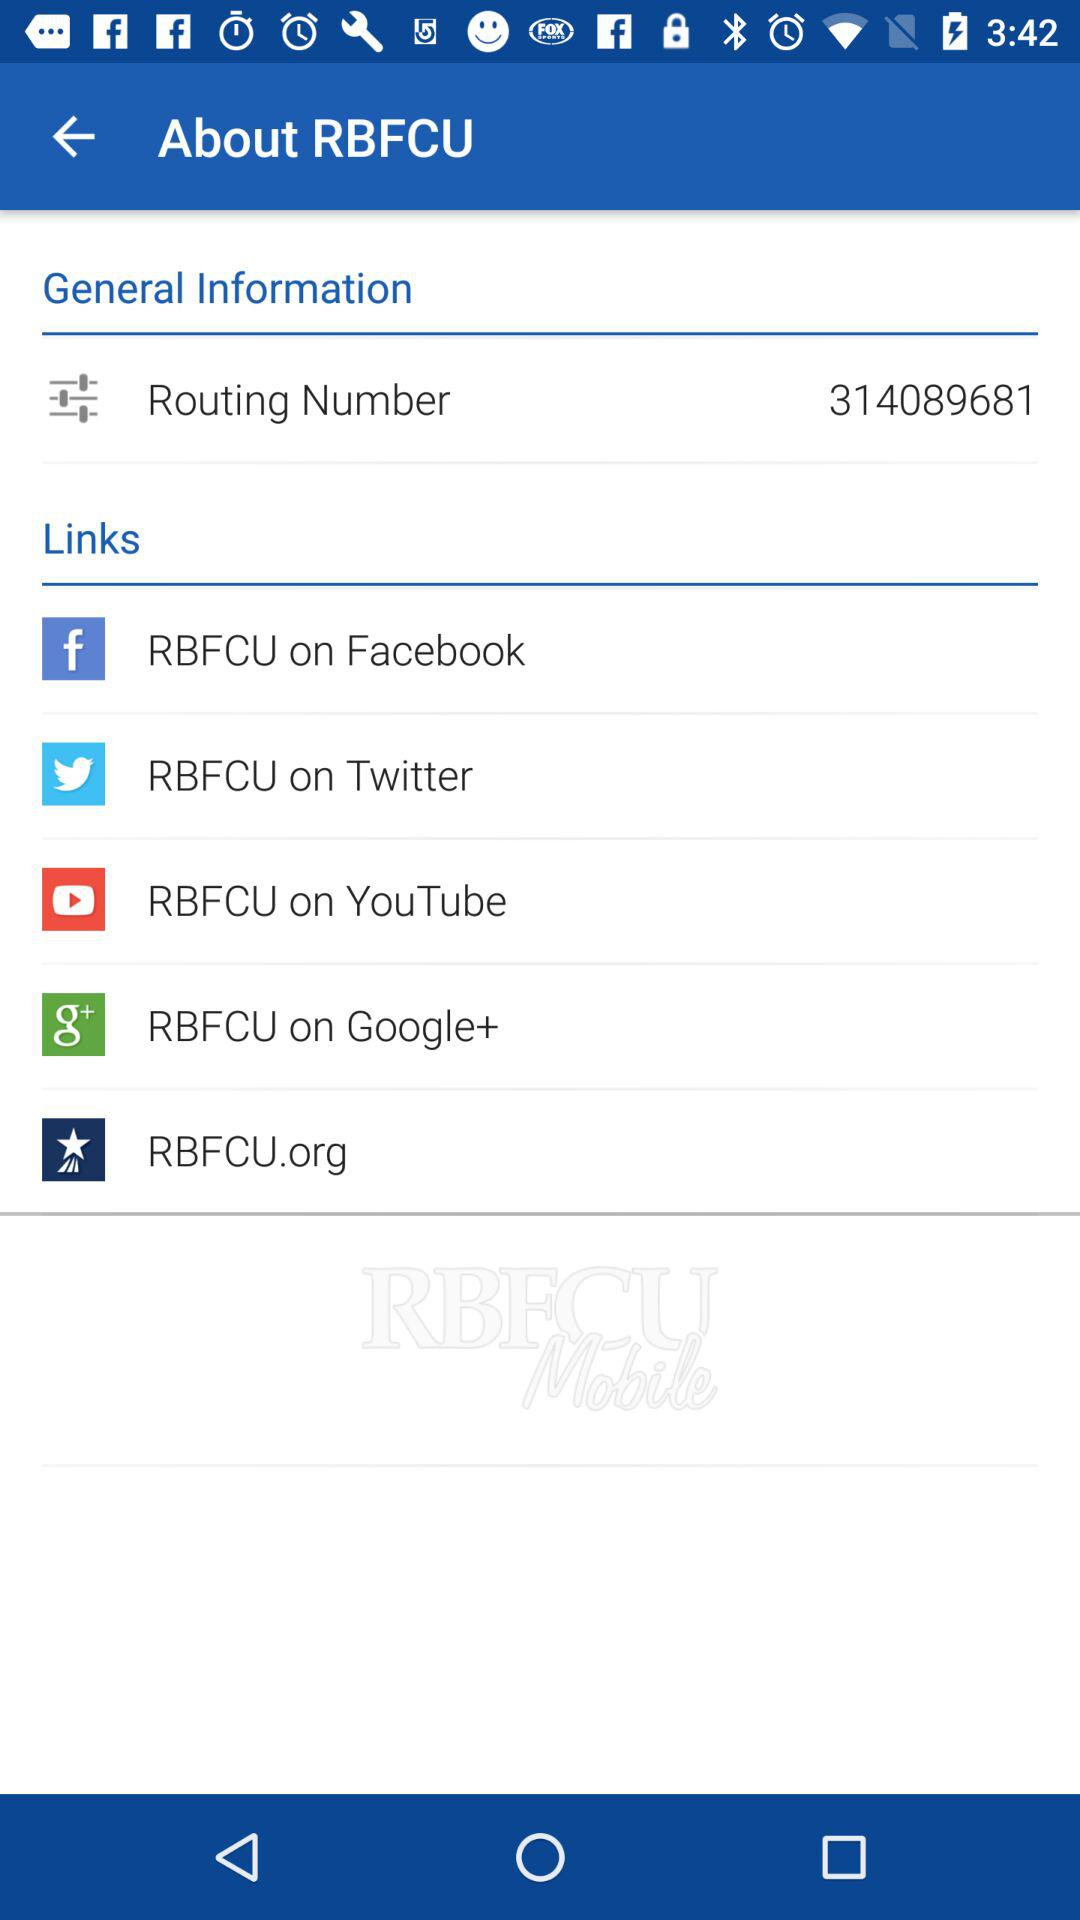What accounts are given links for? The given links are for "Facebook", "Twitter", "YouTube" and "Google+" accounts. 